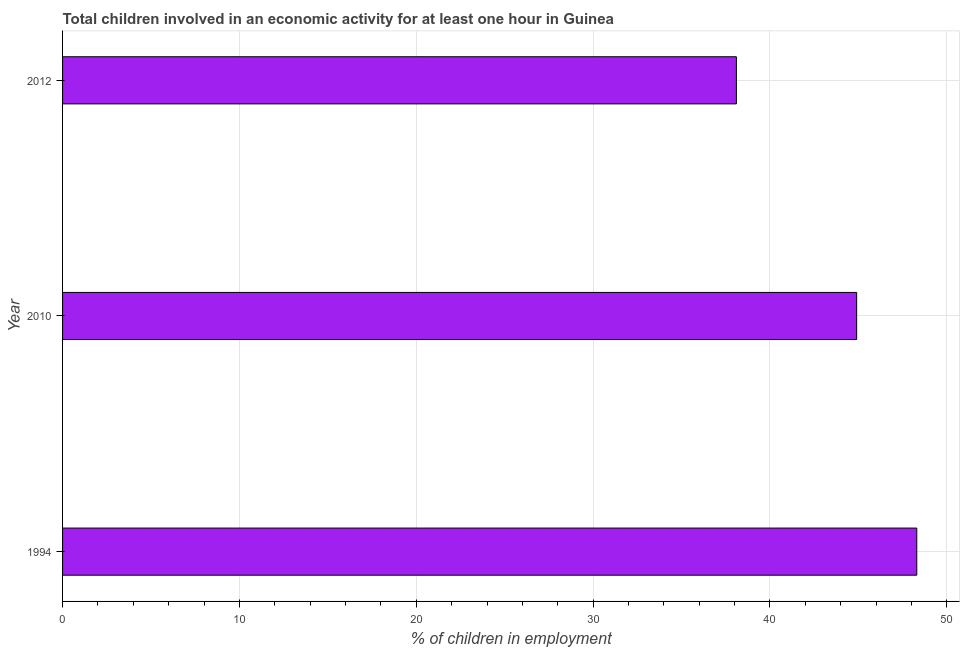What is the title of the graph?
Your answer should be compact. Total children involved in an economic activity for at least one hour in Guinea. What is the label or title of the X-axis?
Keep it short and to the point. % of children in employment. What is the percentage of children in employment in 2012?
Provide a succinct answer. 38.1. Across all years, what is the maximum percentage of children in employment?
Keep it short and to the point. 48.3. Across all years, what is the minimum percentage of children in employment?
Make the answer very short. 38.1. What is the sum of the percentage of children in employment?
Offer a very short reply. 131.3. What is the difference between the percentage of children in employment in 1994 and 2012?
Make the answer very short. 10.2. What is the average percentage of children in employment per year?
Ensure brevity in your answer.  43.77. What is the median percentage of children in employment?
Offer a terse response. 44.9. Do a majority of the years between 1994 and 2012 (inclusive) have percentage of children in employment greater than 26 %?
Give a very brief answer. Yes. What is the ratio of the percentage of children in employment in 2010 to that in 2012?
Make the answer very short. 1.18. Is the percentage of children in employment in 1994 less than that in 2012?
Ensure brevity in your answer.  No. Is the sum of the percentage of children in employment in 1994 and 2012 greater than the maximum percentage of children in employment across all years?
Offer a very short reply. Yes. What is the difference between the highest and the lowest percentage of children in employment?
Provide a short and direct response. 10.2. What is the difference between two consecutive major ticks on the X-axis?
Offer a very short reply. 10. Are the values on the major ticks of X-axis written in scientific E-notation?
Ensure brevity in your answer.  No. What is the % of children in employment in 1994?
Make the answer very short. 48.3. What is the % of children in employment in 2010?
Provide a short and direct response. 44.9. What is the % of children in employment of 2012?
Provide a short and direct response. 38.1. What is the difference between the % of children in employment in 1994 and 2010?
Provide a short and direct response. 3.4. What is the difference between the % of children in employment in 1994 and 2012?
Your answer should be compact. 10.2. What is the difference between the % of children in employment in 2010 and 2012?
Your answer should be very brief. 6.8. What is the ratio of the % of children in employment in 1994 to that in 2010?
Keep it short and to the point. 1.08. What is the ratio of the % of children in employment in 1994 to that in 2012?
Keep it short and to the point. 1.27. What is the ratio of the % of children in employment in 2010 to that in 2012?
Ensure brevity in your answer.  1.18. 